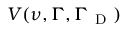<formula> <loc_0><loc_0><loc_500><loc_500>V ( { \nu } , { \Gamma } , { \Gamma } _ { D } )</formula> 